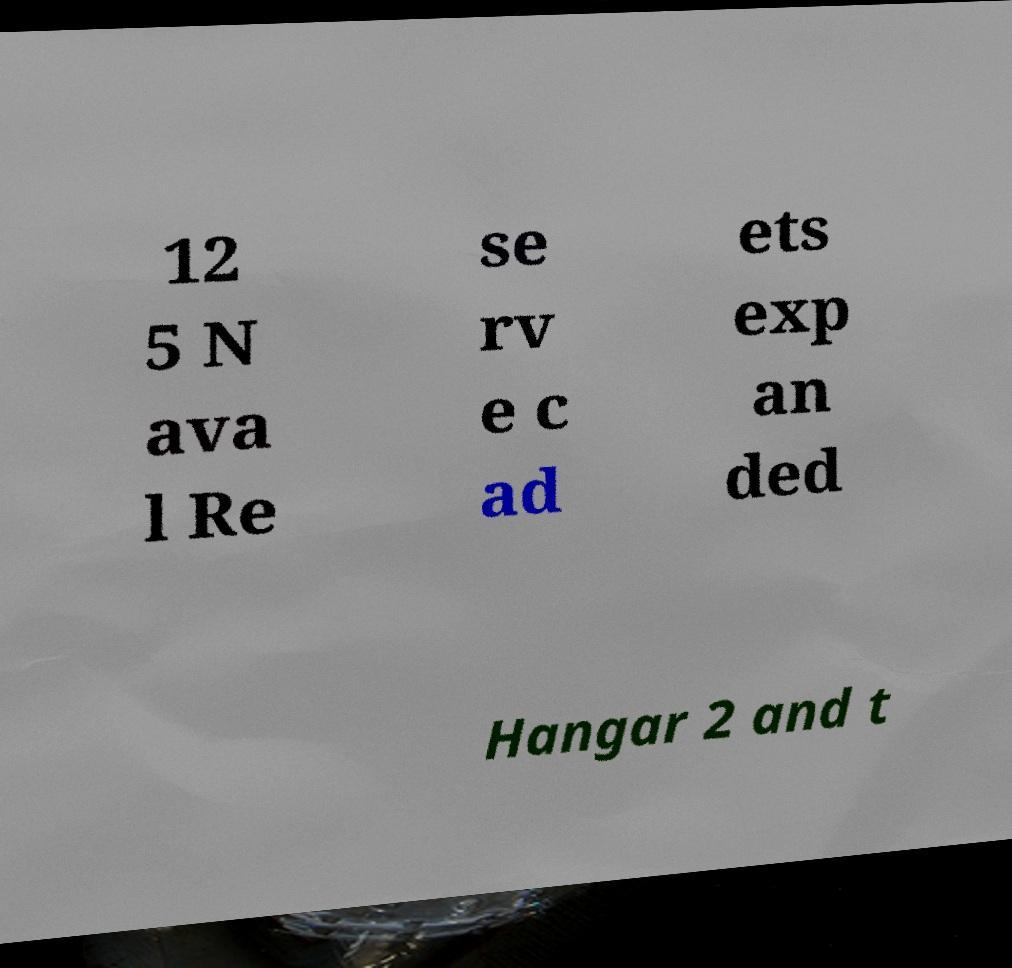Please identify and transcribe the text found in this image. 12 5 N ava l Re se rv e c ad ets exp an ded Hangar 2 and t 